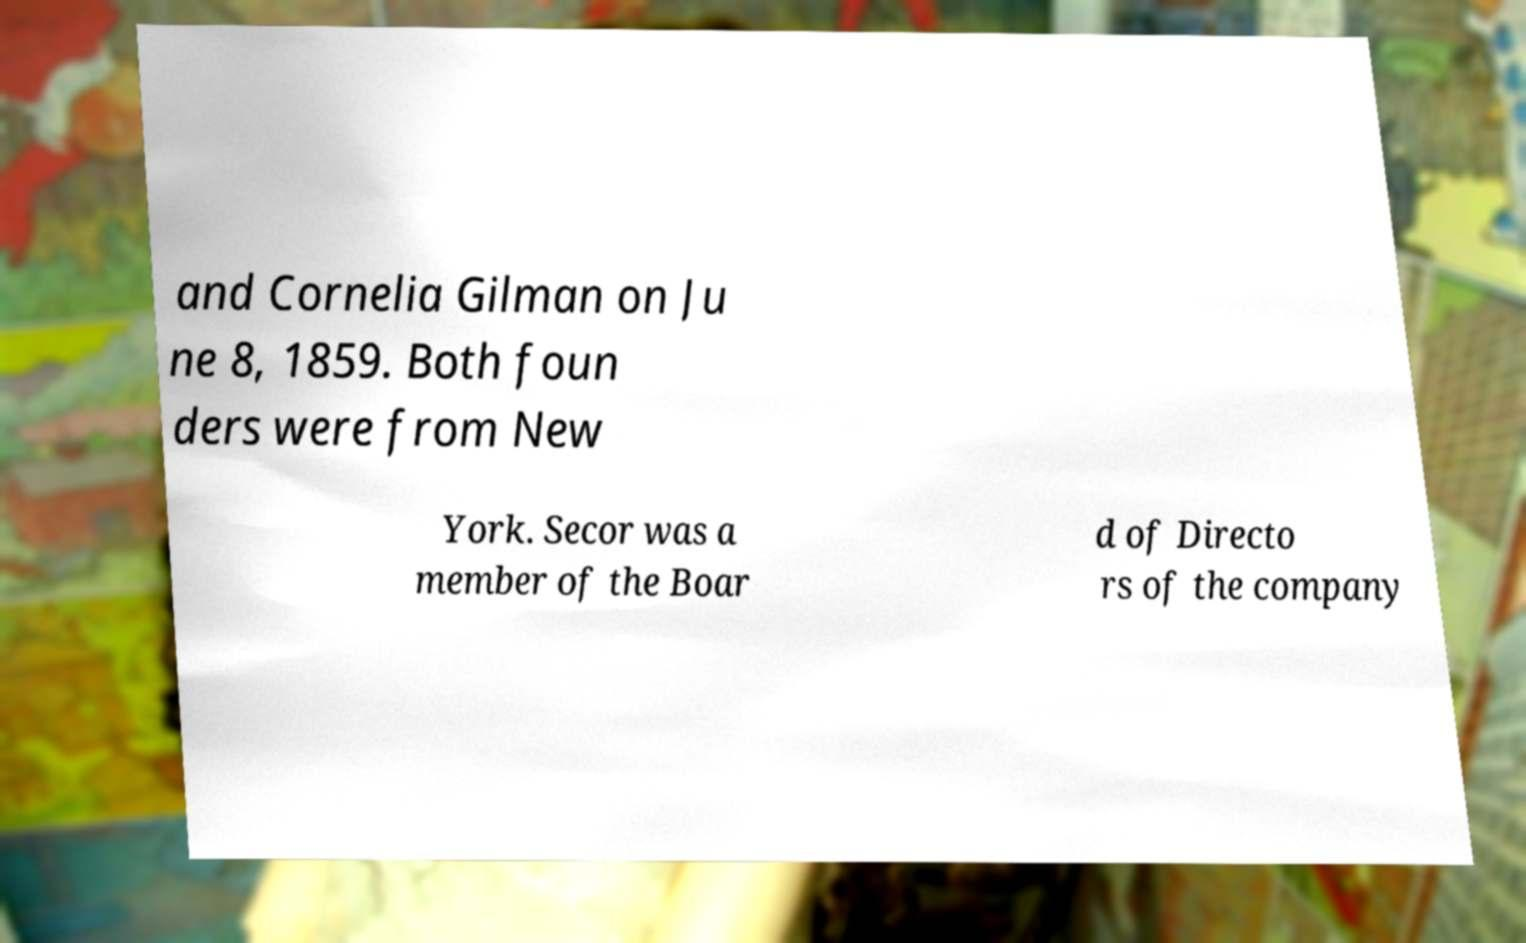I need the written content from this picture converted into text. Can you do that? and Cornelia Gilman on Ju ne 8, 1859. Both foun ders were from New York. Secor was a member of the Boar d of Directo rs of the company 